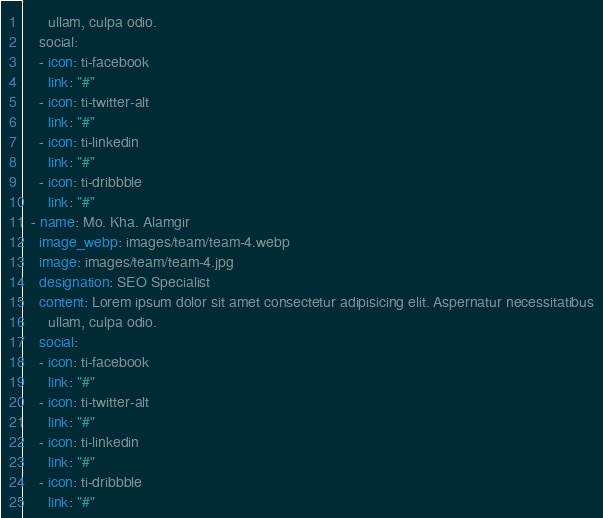<code> <loc_0><loc_0><loc_500><loc_500><_YAML_>      ullam, culpa odio.
    social:
    - icon: ti-facebook
      link: "#"
    - icon: ti-twitter-alt
      link: "#"
    - icon: ti-linkedin
      link: "#"
    - icon: ti-dribbble
      link: "#"
  - name: Mo. Kha. Alamgir
    image_webp: images/team/team-4.webp
    image: images/team/team-4.jpg
    designation: SEO Specialist
    content: Lorem ipsum dolor sit amet consectetur adipisicing elit. Aspernatur necessitatibus
      ullam, culpa odio.
    social:
    - icon: ti-facebook
      link: "#"
    - icon: ti-twitter-alt
      link: "#"
    - icon: ti-linkedin
      link: "#"
    - icon: ti-dribbble
      link: "#"
</code> 